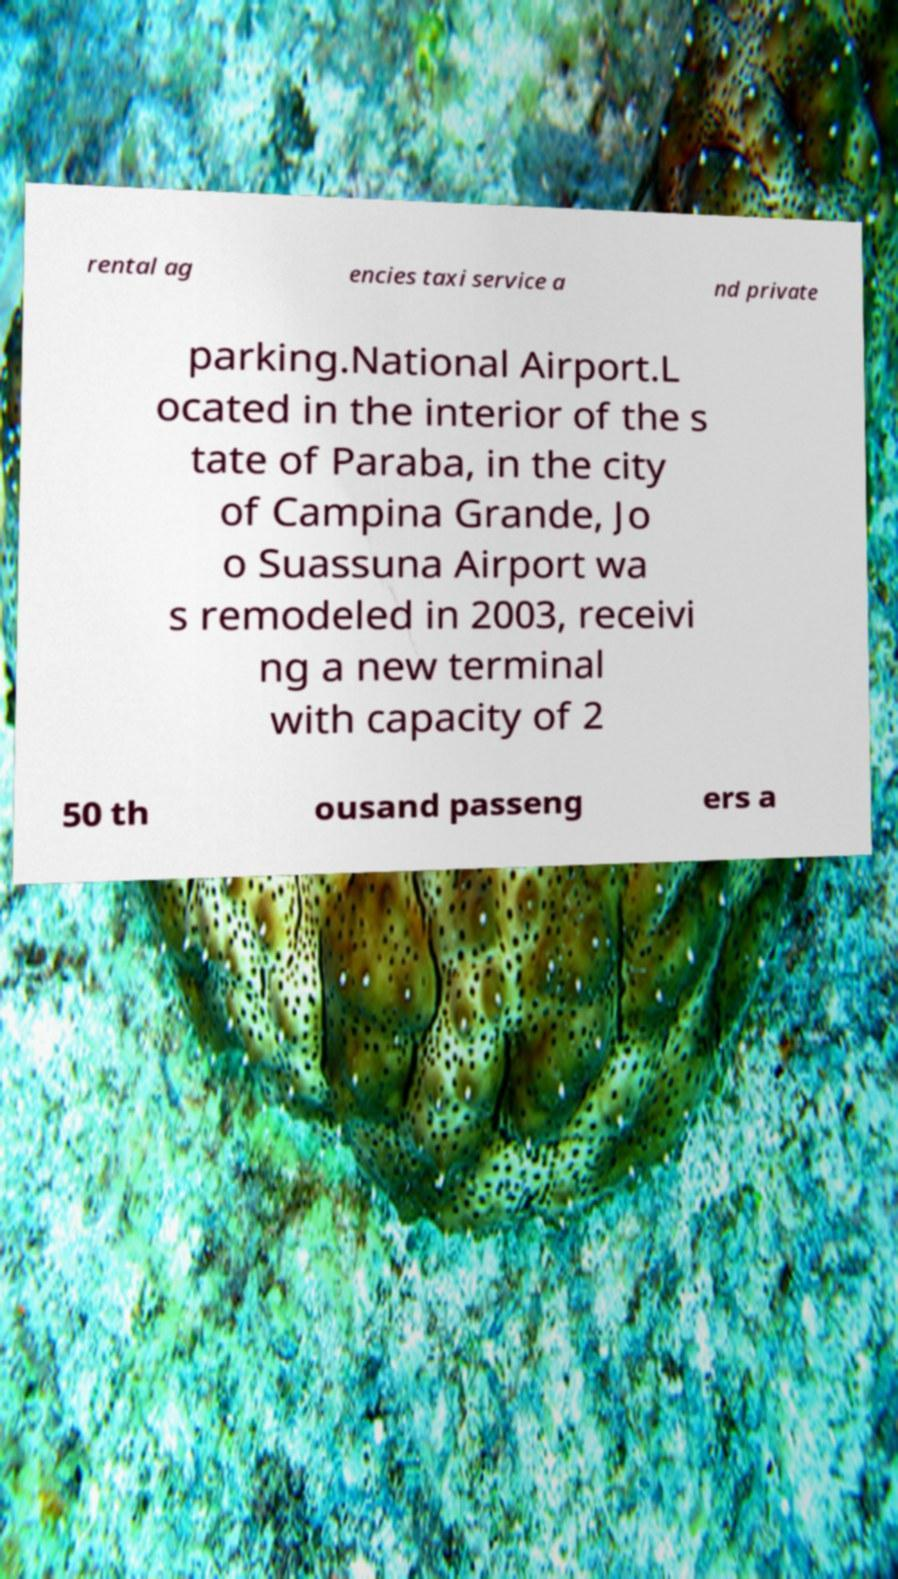I need the written content from this picture converted into text. Can you do that? rental ag encies taxi service a nd private parking.National Airport.L ocated in the interior of the s tate of Paraba, in the city of Campina Grande, Jo o Suassuna Airport wa s remodeled in 2003, receivi ng a new terminal with capacity of 2 50 th ousand passeng ers a 